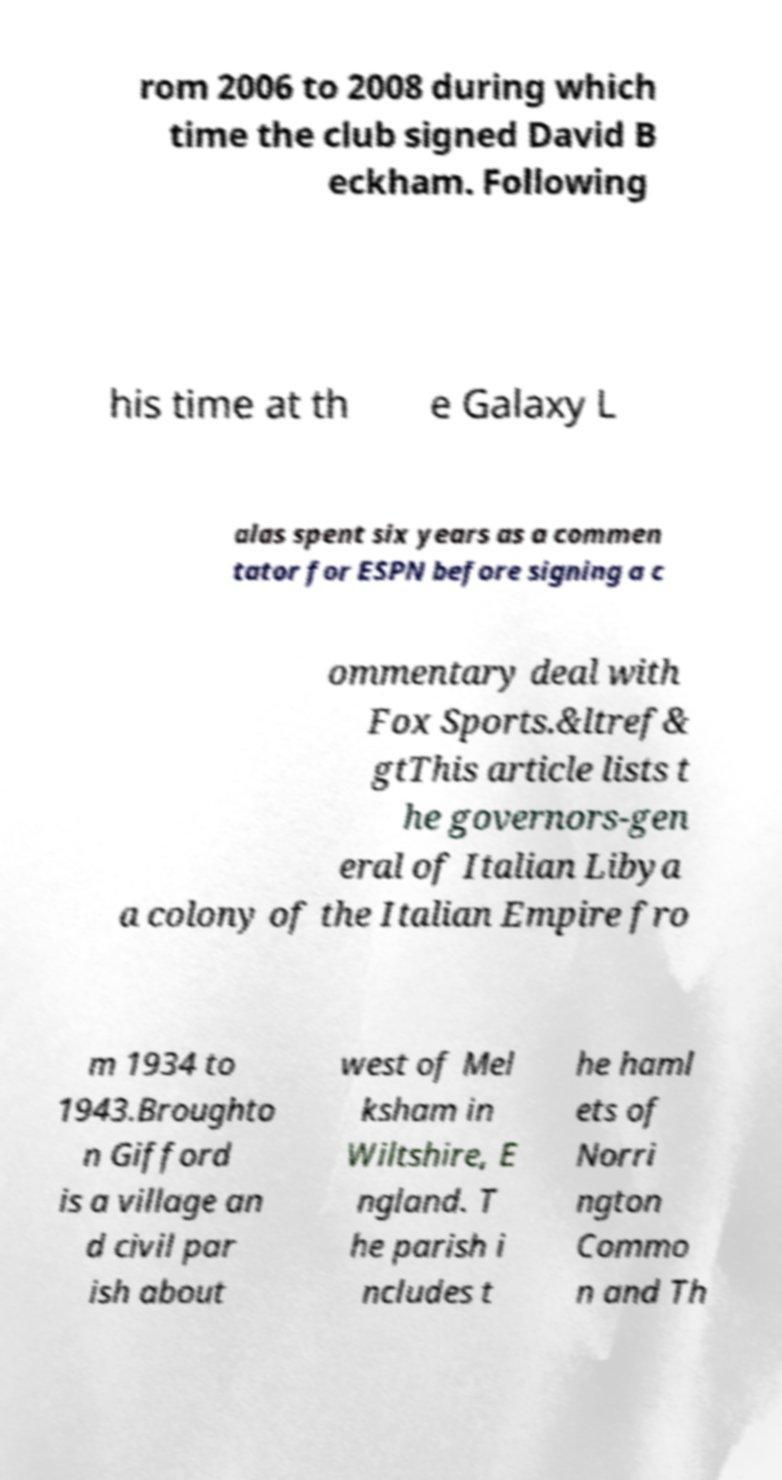Could you extract and type out the text from this image? rom 2006 to 2008 during which time the club signed David B eckham. Following his time at th e Galaxy L alas spent six years as a commen tator for ESPN before signing a c ommentary deal with Fox Sports.&ltref& gtThis article lists t he governors-gen eral of Italian Libya a colony of the Italian Empire fro m 1934 to 1943.Broughto n Gifford is a village an d civil par ish about west of Mel ksham in Wiltshire, E ngland. T he parish i ncludes t he haml ets of Norri ngton Commo n and Th 